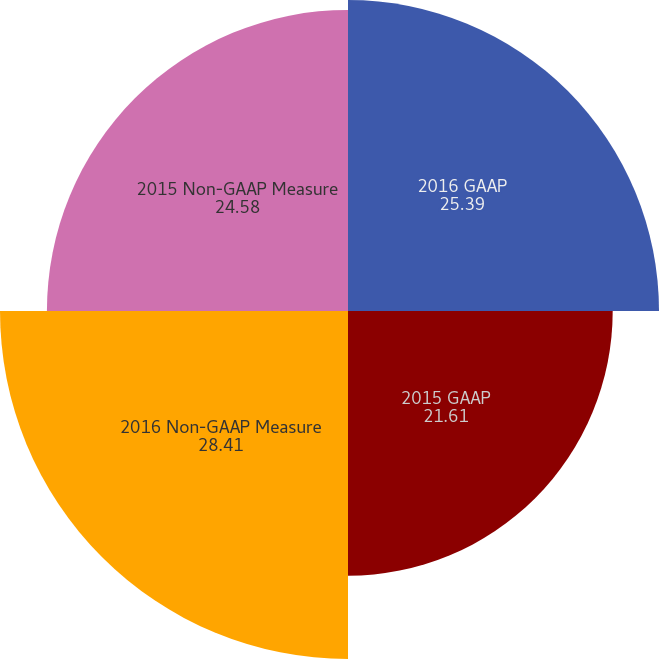<chart> <loc_0><loc_0><loc_500><loc_500><pie_chart><fcel>2016 GAAP<fcel>2015 GAAP<fcel>2016 Non-GAAP Measure<fcel>2015 Non-GAAP Measure<nl><fcel>25.39%<fcel>21.61%<fcel>28.41%<fcel>24.58%<nl></chart> 